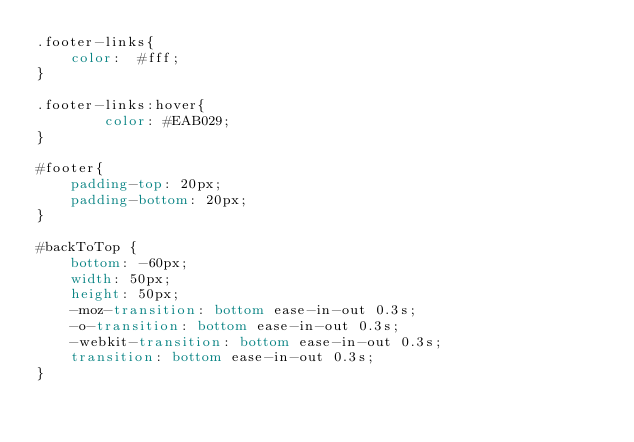Convert code to text. <code><loc_0><loc_0><loc_500><loc_500><_CSS_>.footer-links{
    color:  #fff;
}

.footer-links:hover{
        color: #EAB029;
}

#footer{
    padding-top: 20px;
    padding-bottom: 20px;
}

#backToTop {
    bottom: -60px;
    width: 50px;
    height: 50px;
    -moz-transition: bottom ease-in-out 0.3s;
    -o-transition: bottom ease-in-out 0.3s;
    -webkit-transition: bottom ease-in-out 0.3s;
    transition: bottom ease-in-out 0.3s;
}</code> 